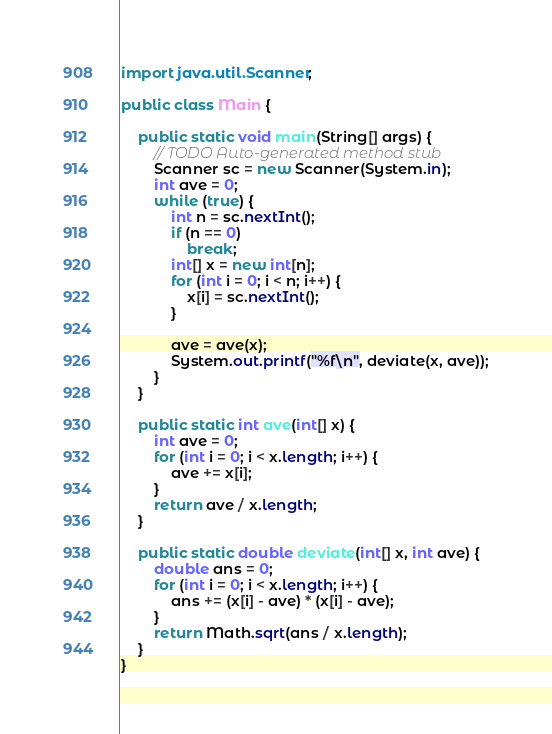Convert code to text. <code><loc_0><loc_0><loc_500><loc_500><_Java_>import java.util.Scanner;

public class Main {

	public static void main(String[] args) {
		// TODO Auto-generated method stub
		Scanner sc = new Scanner(System.in);
		int ave = 0;
		while (true) {
			int n = sc.nextInt();
			if (n == 0)
				break;
			int[] x = new int[n];
			for (int i = 0; i < n; i++) {
				x[i] = sc.nextInt();
			}

			ave = ave(x);
			System.out.printf("%f\n", deviate(x, ave));
		}
	}

	public static int ave(int[] x) {
		int ave = 0;
		for (int i = 0; i < x.length; i++) {
			ave += x[i];
		}
		return ave / x.length;
	}

	public static double deviate(int[] x, int ave) {
		double ans = 0;
		for (int i = 0; i < x.length; i++) {
			ans += (x[i] - ave) * (x[i] - ave);
		}
		return Math.sqrt(ans / x.length);
	}
}</code> 